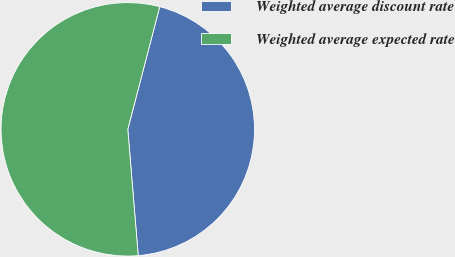Convert chart to OTSL. <chart><loc_0><loc_0><loc_500><loc_500><pie_chart><fcel>Weighted average discount rate<fcel>Weighted average expected rate<nl><fcel>44.63%<fcel>55.37%<nl></chart> 